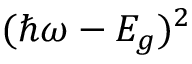<formula> <loc_0><loc_0><loc_500><loc_500>( \hbar { \omega } - E _ { g } ) ^ { 2 }</formula> 